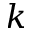<formula> <loc_0><loc_0><loc_500><loc_500>k</formula> 